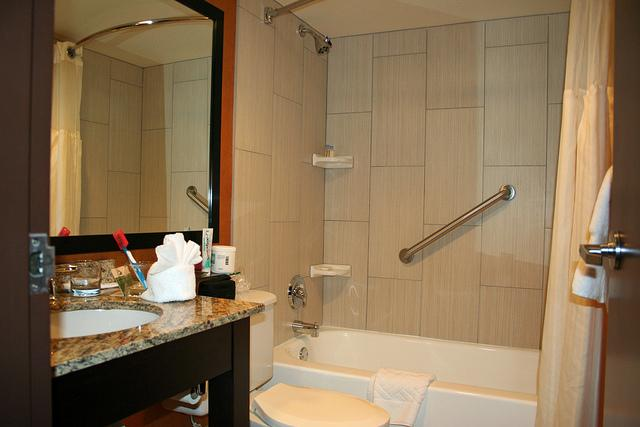What is the blue/white/red item by the sink? Please explain your reasoning. toothbrush. The item is a toothbrush. 